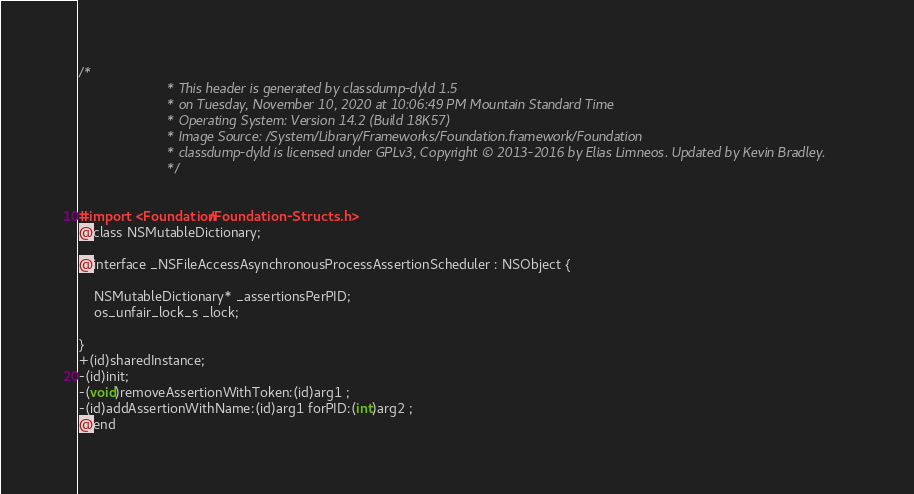Convert code to text. <code><loc_0><loc_0><loc_500><loc_500><_C_>/*
                       * This header is generated by classdump-dyld 1.5
                       * on Tuesday, November 10, 2020 at 10:06:49 PM Mountain Standard Time
                       * Operating System: Version 14.2 (Build 18K57)
                       * Image Source: /System/Library/Frameworks/Foundation.framework/Foundation
                       * classdump-dyld is licensed under GPLv3, Copyright © 2013-2016 by Elias Limneos. Updated by Kevin Bradley.
                       */


#import <Foundation/Foundation-Structs.h>
@class NSMutableDictionary;

@interface _NSFileAccessAsynchronousProcessAssertionScheduler : NSObject {

	NSMutableDictionary* _assertionsPerPID;
	os_unfair_lock_s _lock;

}
+(id)sharedInstance;
-(id)init;
-(void)removeAssertionWithToken:(id)arg1 ;
-(id)addAssertionWithName:(id)arg1 forPID:(int)arg2 ;
@end

</code> 